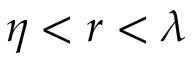Convert formula to latex. <formula><loc_0><loc_0><loc_500><loc_500>\eta < r < \lambda</formula> 